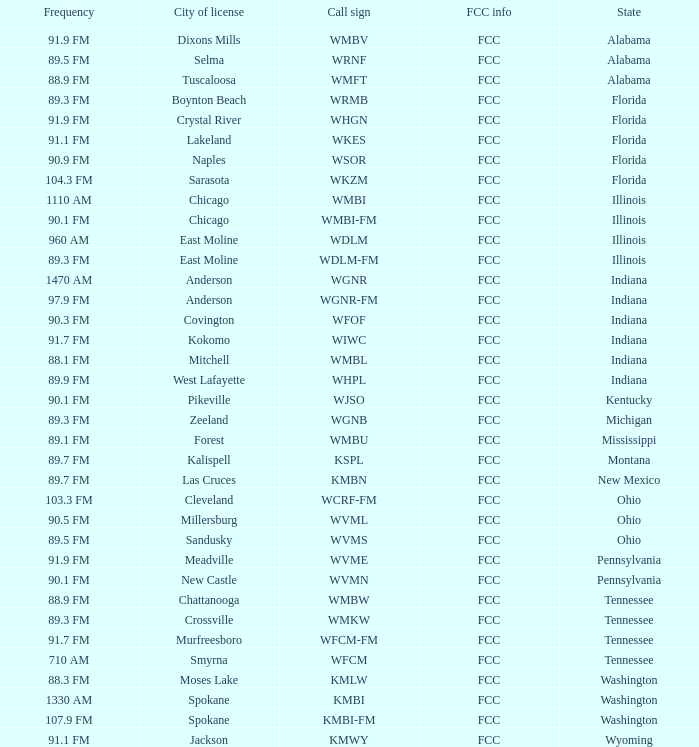What is the FCC info for the radio station in West Lafayette, Indiana? FCC. 